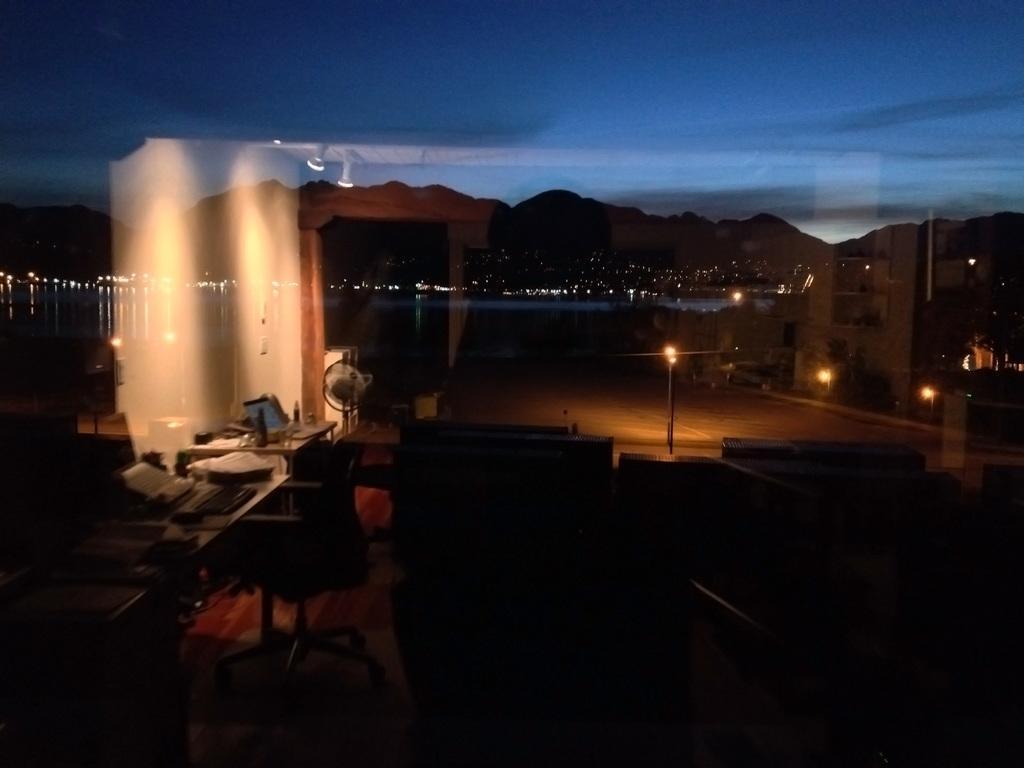How would you summarize this image in a sentence or two? In the given image i can see a tables,bottles,lights,mountains,chairs and some other objects. 